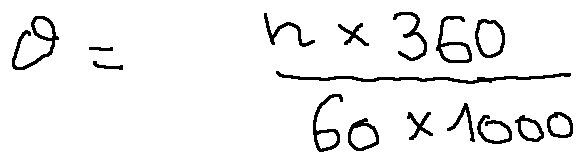Convert formula to latex. <formula><loc_0><loc_0><loc_500><loc_500>\theta = \frac { n \times 3 6 0 } { 6 0 \times 1 0 0 0 }</formula> 